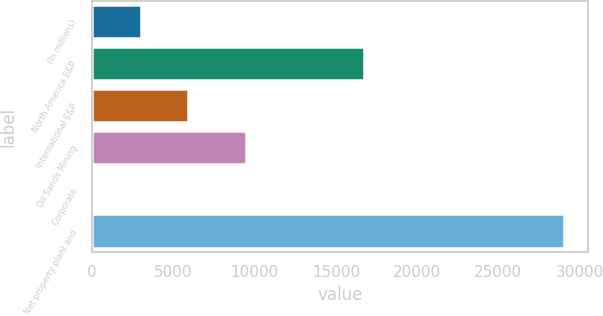Convert chart to OTSL. <chart><loc_0><loc_0><loc_500><loc_500><bar_chart><fcel>(In millions)<fcel>North America E&P<fcel>International E&P<fcel>Oil Sands Mining<fcel>Corporate<fcel>Net property plant and<nl><fcel>3018.3<fcel>16717<fcel>5909.6<fcel>9455<fcel>127<fcel>29040<nl></chart> 